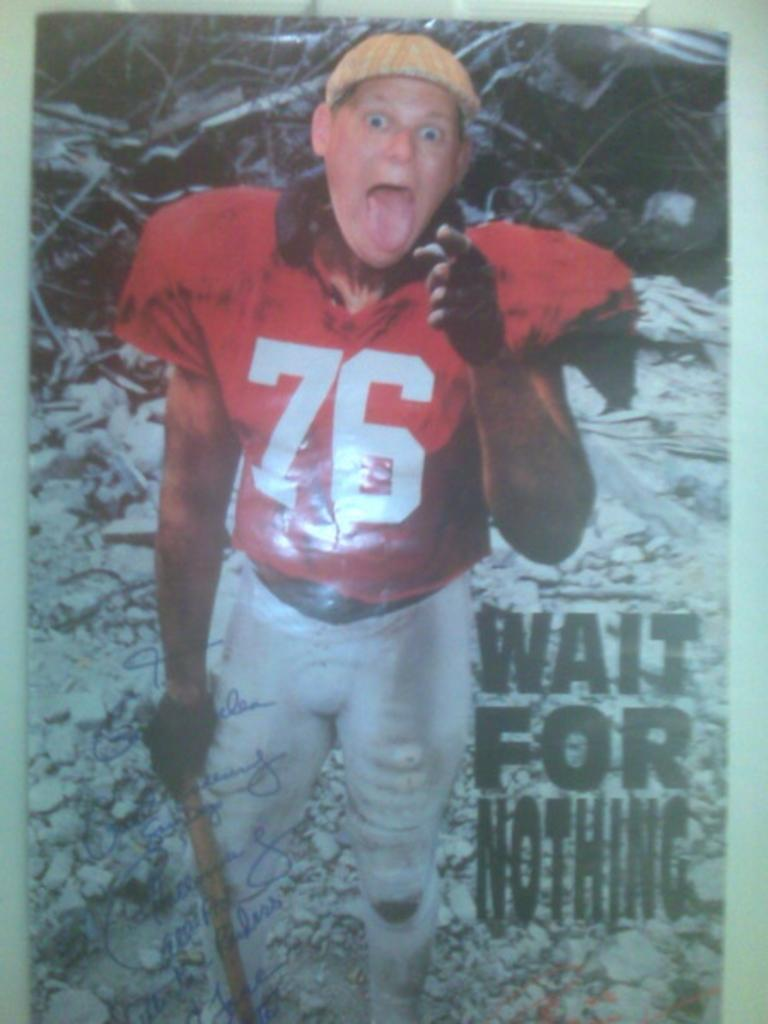<image>
Write a terse but informative summary of the picture. A person wears a football uniform, next to him is text about waiting for nothing. 